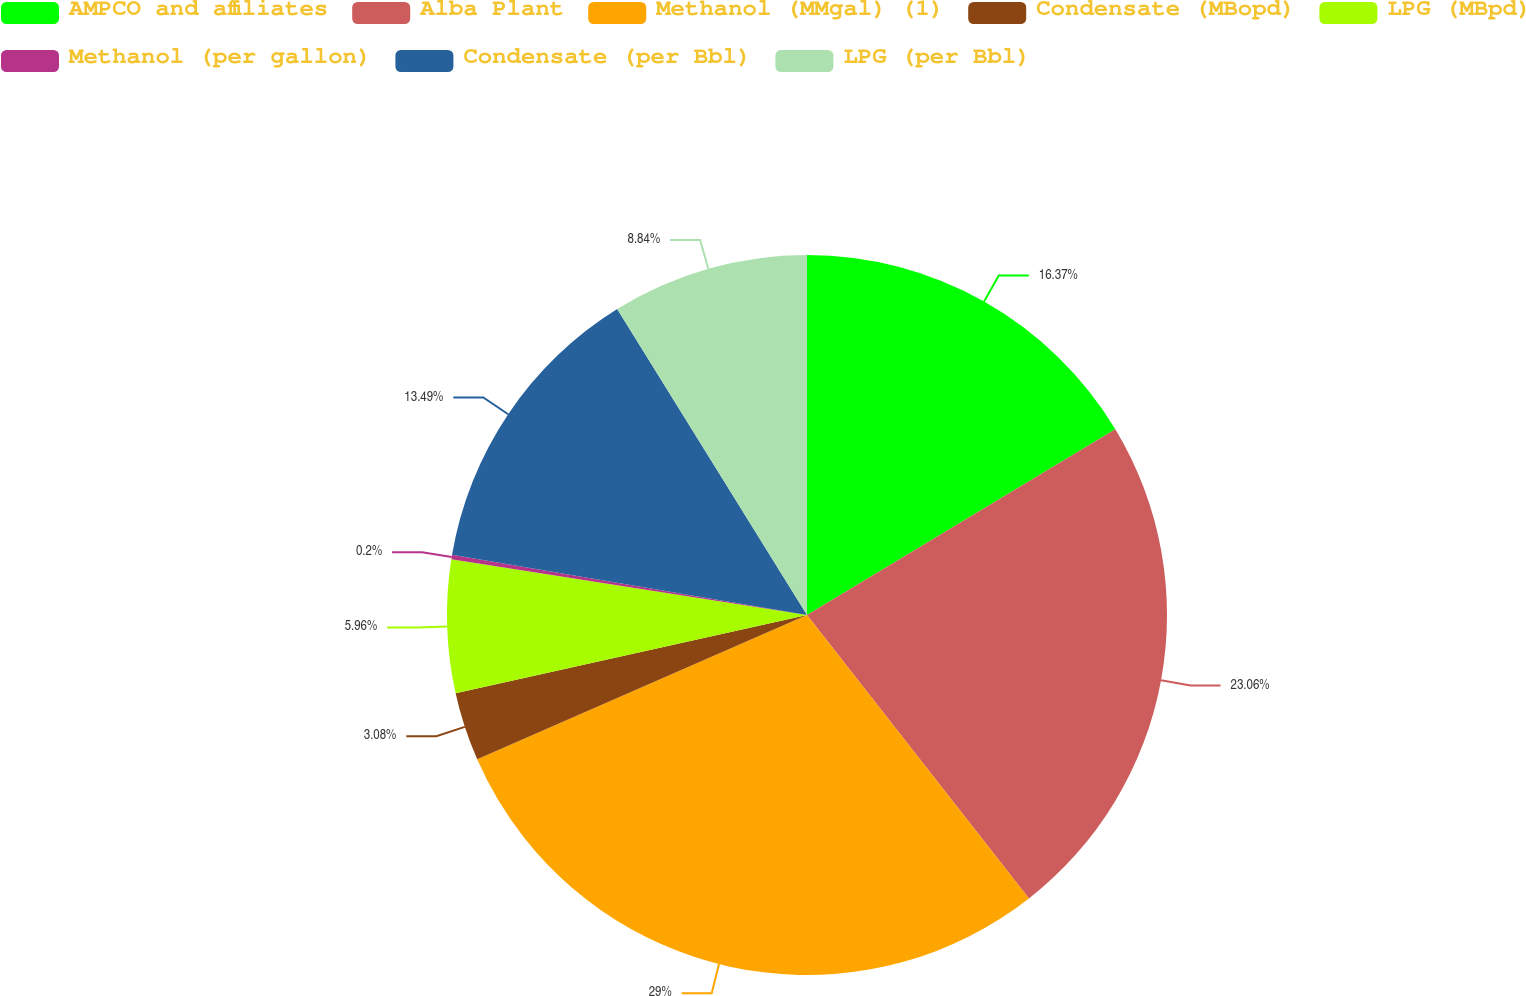Convert chart. <chart><loc_0><loc_0><loc_500><loc_500><pie_chart><fcel>AMPCO and affiliates<fcel>Alba Plant<fcel>Methanol (MMgal) (1)<fcel>Condensate (MBopd)<fcel>LPG (MBpd)<fcel>Methanol (per gallon)<fcel>Condensate (per Bbl)<fcel>LPG (per Bbl)<nl><fcel>16.37%<fcel>23.06%<fcel>29.01%<fcel>3.08%<fcel>5.96%<fcel>0.2%<fcel>13.49%<fcel>8.84%<nl></chart> 